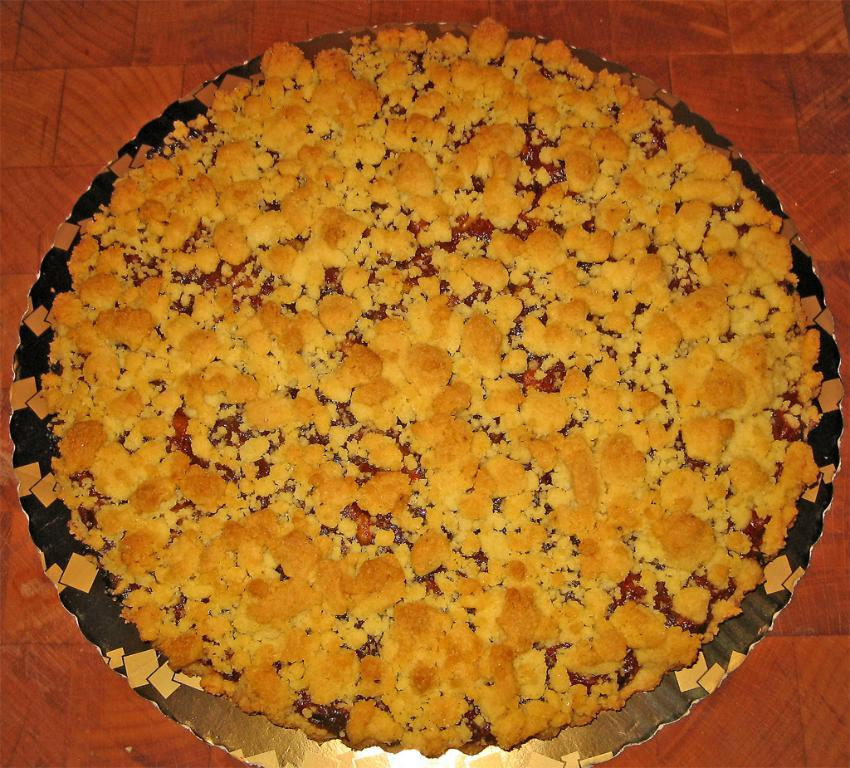What color are the tiles in the image? The tiles in the image are orange. What else can be seen in the image besides the tiles? There is a dish in the image. What type of lawyer is depicted in the image? There is no lawyer present in the image; it only features orange color tiles and a dish. How many spoons are visible in the image? There is no spoon present in the image. 